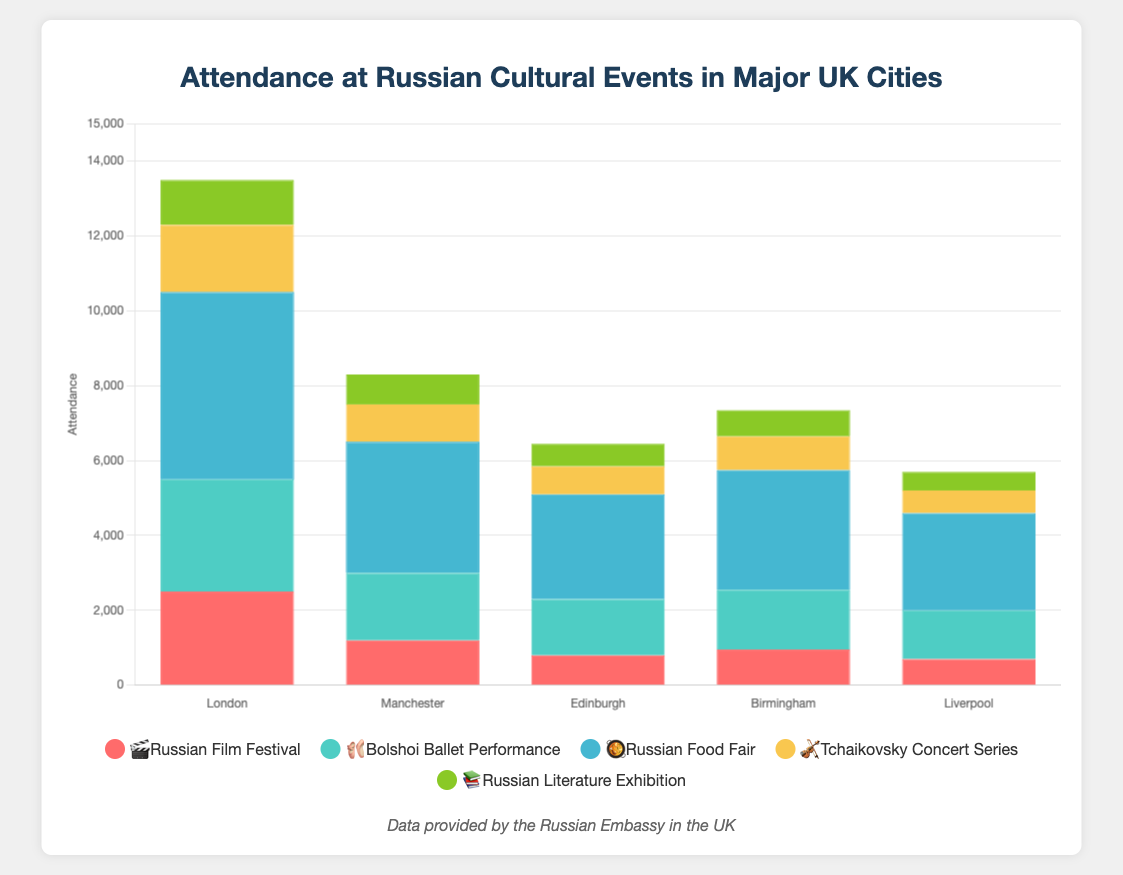What's the highest attendance for the Russian Food Fair 🥘? Look at the data for the Russian Food Fair 🥘. The attendance for each city is listed. Find the maximum number in this list, which is 5000 in London.
Answer: 5000 Which event had the lowest attendance in Liverpool 📚? Look at the data for Liverpool and find the lowest attendance value across all events. The lowest value is 500 for the Russian Literature Exhibition 📚.
Answer: Russian Literature Exhibition 📚 How does the attendance for the Tchaikovsky Concert Series 🎻 in Edinburgh compare to Manchester? Look at the attendance numbers for the Tchaikovsky Concert Series 🎻 in both cities. In Edinburgh, it is 750, whereas in Manchester, it is 1000. Compare these values.
Answer: Edinburgh has lower attendance What is the average attendance of the Bolshoi Ballet Performance 🩰 across all cities? Sum up the attendance numbers for the Bolshoi Ballet Performance 🩰 (3000 + 1800 + 1500 + 1600 + 1300) and divide by the number of cities (5). The calculation is (3000 + 1800 + 1500 + 1600 + 1300) / 5 = 9200 / 5 = 1840.
Answer: 1840 Which city had the highest overall attendance across all events? Sum the attendance of all events for each city. Identify the city with the highest total attendance. For London, the total is 13500, for Manchester, it is 8300, for Edinburgh, it is 6450, for Birmingham, it is 7350, and for Liverpool, it is 5700. So, London has the highest overall attendance.
Answer: London What is the difference in attendance between the Russian Film Festival 🎬 and the Russian Food Fair 🥘 in Birmingham? Look at the attendance numbers for both events in Birmingham. For the Russian Film Festival 🎬, it is 950, and for the Russian Food Fair 🥘, it is 3200. The difference is 3200 - 950 = 2250.
Answer: 2250 Which event had the most varied attendance across different cities? Calculate the range (difference between maximum and minimum attendance) for each event. The event with the highest range is the Russian Food Fair 🥘 (5000 - 2600 = 2400), followed by other events with smaller ranges.
Answer: Russian Food Fair 🥘 What is the total attendance for Russian cultural events in Manchester? Add up the attendance numbers for all events in Manchester: 1200 + 1800 + 3500 + 1000 + 800 = 8300.
Answer: 8300 Which city showed the lowest interest in the Tchaikovsky Concert Series 🎻? Identify the city with the lowest attendance number for the Tchaikovsky Concert Series 🎻. The lowest number is 600 in Liverpool.
Answer: Liverpool 